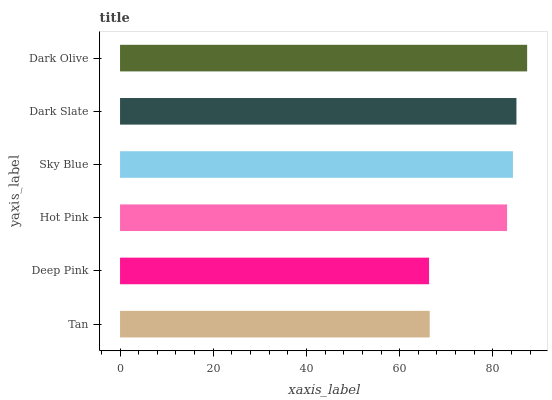Is Deep Pink the minimum?
Answer yes or no. Yes. Is Dark Olive the maximum?
Answer yes or no. Yes. Is Hot Pink the minimum?
Answer yes or no. No. Is Hot Pink the maximum?
Answer yes or no. No. Is Hot Pink greater than Deep Pink?
Answer yes or no. Yes. Is Deep Pink less than Hot Pink?
Answer yes or no. Yes. Is Deep Pink greater than Hot Pink?
Answer yes or no. No. Is Hot Pink less than Deep Pink?
Answer yes or no. No. Is Sky Blue the high median?
Answer yes or no. Yes. Is Hot Pink the low median?
Answer yes or no. Yes. Is Dark Slate the high median?
Answer yes or no. No. Is Tan the low median?
Answer yes or no. No. 